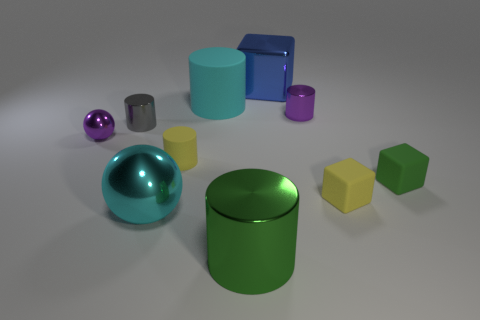Are there any rubber cylinders?
Offer a terse response. Yes. What size is the metallic cylinder that is on the right side of the small gray metal thing and on the left side of the tiny purple metal cylinder?
Make the answer very short. Large. Is the number of tiny purple shiny objects that are in front of the green metal cylinder greater than the number of large rubber objects that are behind the big block?
Keep it short and to the point. No. What is the size of the ball that is the same color as the large matte cylinder?
Make the answer very short. Large. The tiny ball has what color?
Make the answer very short. Purple. What is the color of the big object that is right of the large matte cylinder and behind the green matte thing?
Your response must be concise. Blue. What is the color of the small metallic object behind the metal cylinder on the left side of the big cyan object behind the small green object?
Give a very brief answer. Purple. The shiny sphere that is the same size as the yellow matte cylinder is what color?
Your answer should be very brief. Purple. There is a tiny purple thing that is to the left of the large cylinder in front of the large cylinder behind the tiny purple sphere; what shape is it?
Give a very brief answer. Sphere. The tiny shiny object that is the same color as the tiny metal ball is what shape?
Offer a very short reply. Cylinder. 